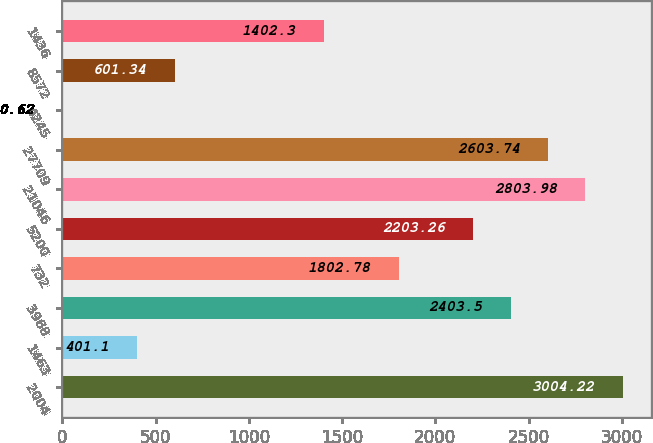Convert chart. <chart><loc_0><loc_0><loc_500><loc_500><bar_chart><fcel>2004<fcel>1463<fcel>3968<fcel>732<fcel>5200<fcel>21046<fcel>27709<fcel>4245<fcel>8572<fcel>1436<nl><fcel>3004.22<fcel>401.1<fcel>2403.5<fcel>1802.78<fcel>2203.26<fcel>2803.98<fcel>2603.74<fcel>0.62<fcel>601.34<fcel>1402.3<nl></chart> 